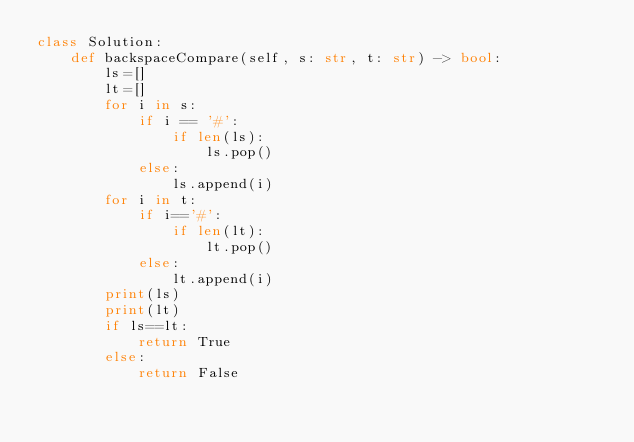Convert code to text. <code><loc_0><loc_0><loc_500><loc_500><_Python_>class Solution:
    def backspaceCompare(self, s: str, t: str) -> bool:
        ls=[]
        lt=[]
        for i in s:
            if i == '#':
                if len(ls):
                    ls.pop()
            else:
                ls.append(i)
        for i in t:
            if i=='#':
                if len(lt):
                    lt.pop()
            else:
                lt.append(i)
        print(ls)
        print(lt)
        if ls==lt:
            return True
        else:
            return False</code> 